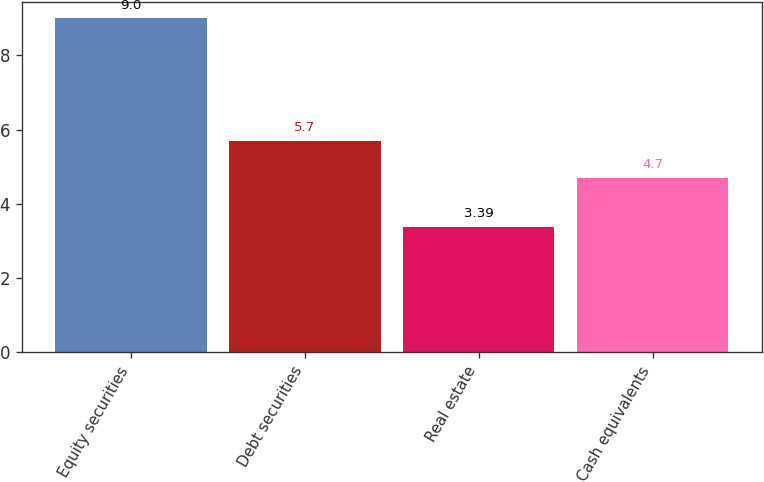Convert chart to OTSL. <chart><loc_0><loc_0><loc_500><loc_500><bar_chart><fcel>Equity securities<fcel>Debt securities<fcel>Real estate<fcel>Cash equivalents<nl><fcel>9<fcel>5.7<fcel>3.39<fcel>4.7<nl></chart> 